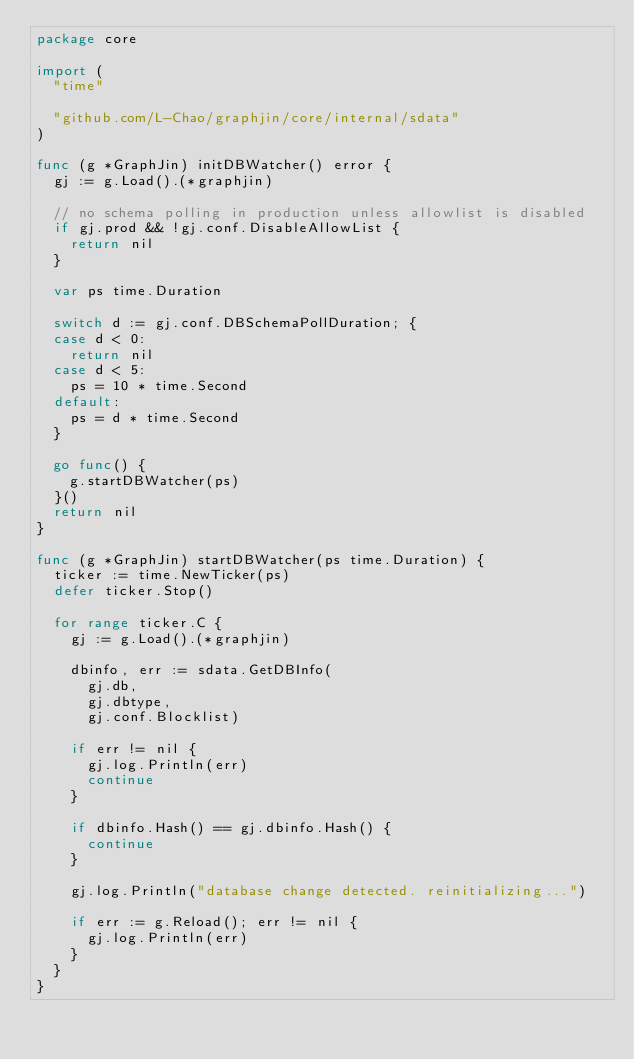Convert code to text. <code><loc_0><loc_0><loc_500><loc_500><_Go_>package core

import (
	"time"

	"github.com/L-Chao/graphjin/core/internal/sdata"
)

func (g *GraphJin) initDBWatcher() error {
	gj := g.Load().(*graphjin)

	// no schema polling in production unless allowlist is disabled
	if gj.prod && !gj.conf.DisableAllowList {
		return nil
	}

	var ps time.Duration

	switch d := gj.conf.DBSchemaPollDuration; {
	case d < 0:
		return nil
	case d < 5:
		ps = 10 * time.Second
	default:
		ps = d * time.Second
	}

	go func() {
		g.startDBWatcher(ps)
	}()
	return nil
}

func (g *GraphJin) startDBWatcher(ps time.Duration) {
	ticker := time.NewTicker(ps)
	defer ticker.Stop()

	for range ticker.C {
		gj := g.Load().(*graphjin)

		dbinfo, err := sdata.GetDBInfo(
			gj.db,
			gj.dbtype,
			gj.conf.Blocklist)

		if err != nil {
			gj.log.Println(err)
			continue
		}

		if dbinfo.Hash() == gj.dbinfo.Hash() {
			continue
		}

		gj.log.Println("database change detected. reinitializing...")

		if err := g.Reload(); err != nil {
			gj.log.Println(err)
		}
	}
}
</code> 